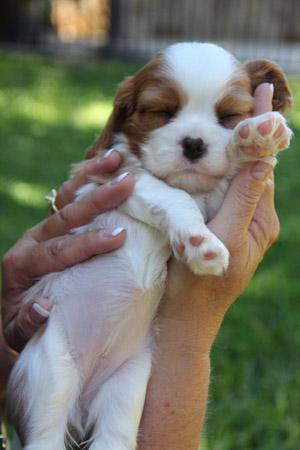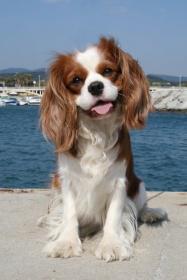The first image is the image on the left, the second image is the image on the right. For the images shown, is this caption "A brown-and-white spaniel puppy is held in a human hand outdoors." true? Answer yes or no. Yes. The first image is the image on the left, the second image is the image on the right. Examine the images to the left and right. Is the description "At least one of the puppies is indoors." accurate? Answer yes or no. No. 